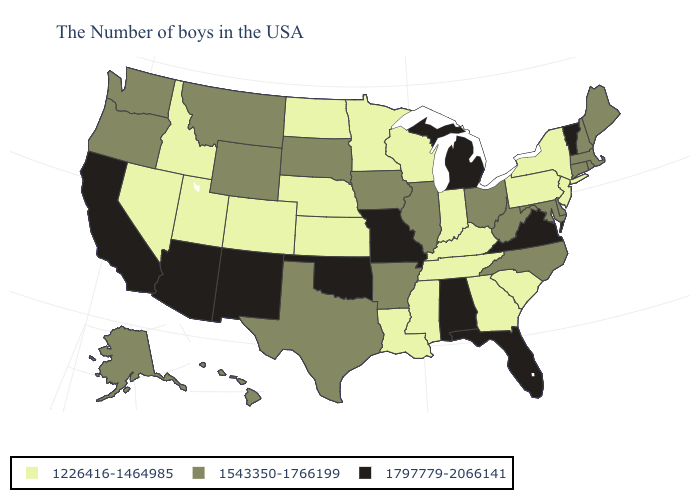Name the states that have a value in the range 1226416-1464985?
Keep it brief. New York, New Jersey, Pennsylvania, South Carolina, Georgia, Kentucky, Indiana, Tennessee, Wisconsin, Mississippi, Louisiana, Minnesota, Kansas, Nebraska, North Dakota, Colorado, Utah, Idaho, Nevada. Is the legend a continuous bar?
Keep it brief. No. Name the states that have a value in the range 1797779-2066141?
Give a very brief answer. Vermont, Virginia, Florida, Michigan, Alabama, Missouri, Oklahoma, New Mexico, Arizona, California. Does Utah have the lowest value in the USA?
Short answer required. Yes. Does the map have missing data?
Give a very brief answer. No. Does South Carolina have a lower value than Maryland?
Short answer required. Yes. What is the highest value in the USA?
Write a very short answer. 1797779-2066141. Name the states that have a value in the range 1543350-1766199?
Short answer required. Maine, Massachusetts, Rhode Island, New Hampshire, Connecticut, Delaware, Maryland, North Carolina, West Virginia, Ohio, Illinois, Arkansas, Iowa, Texas, South Dakota, Wyoming, Montana, Washington, Oregon, Alaska, Hawaii. Name the states that have a value in the range 1543350-1766199?
Answer briefly. Maine, Massachusetts, Rhode Island, New Hampshire, Connecticut, Delaware, Maryland, North Carolina, West Virginia, Ohio, Illinois, Arkansas, Iowa, Texas, South Dakota, Wyoming, Montana, Washington, Oregon, Alaska, Hawaii. Name the states that have a value in the range 1797779-2066141?
Quick response, please. Vermont, Virginia, Florida, Michigan, Alabama, Missouri, Oklahoma, New Mexico, Arizona, California. What is the lowest value in the USA?
Short answer required. 1226416-1464985. Name the states that have a value in the range 1543350-1766199?
Answer briefly. Maine, Massachusetts, Rhode Island, New Hampshire, Connecticut, Delaware, Maryland, North Carolina, West Virginia, Ohio, Illinois, Arkansas, Iowa, Texas, South Dakota, Wyoming, Montana, Washington, Oregon, Alaska, Hawaii. Which states have the highest value in the USA?
Quick response, please. Vermont, Virginia, Florida, Michigan, Alabama, Missouri, Oklahoma, New Mexico, Arizona, California. What is the highest value in the South ?
Be succinct. 1797779-2066141. Which states have the highest value in the USA?
Concise answer only. Vermont, Virginia, Florida, Michigan, Alabama, Missouri, Oklahoma, New Mexico, Arizona, California. 